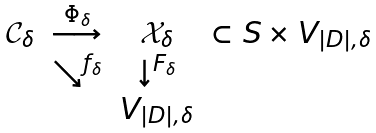Convert formula to latex. <formula><loc_0><loc_0><loc_500><loc_500>\begin{array} { c c c l } { \mathcal { C } } _ { \delta } & \stackrel { \Phi _ { \delta } } { \longrightarrow } & { \mathcal { X } } _ { \delta } & \subset S \times V _ { | D | , \delta } \\ & \searrow ^ { f _ { \delta } } & \downarrow ^ { F _ { \delta } } & \\ & & V _ { | D | , \delta } & \end{array}</formula> 